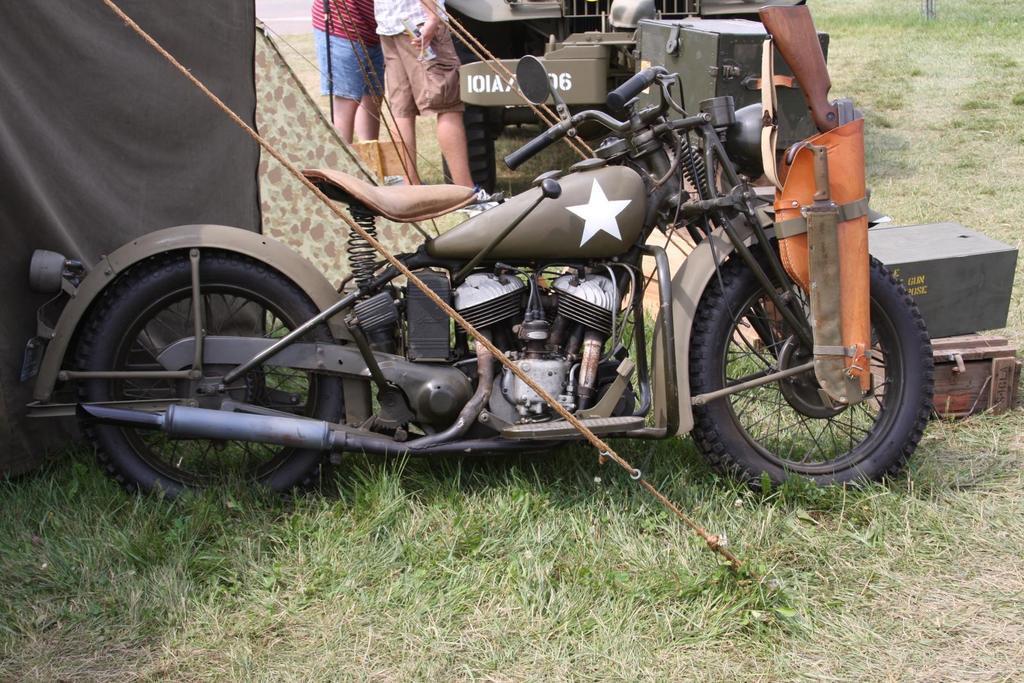Can you describe this image briefly? In this I can see a motorcycle and a jeep and I can see few wooden boxes on the ground and I can see a gun to the motorcycle and a knife and I can see a tent on the left side and couple of them standing and I can see grass on the ground. 